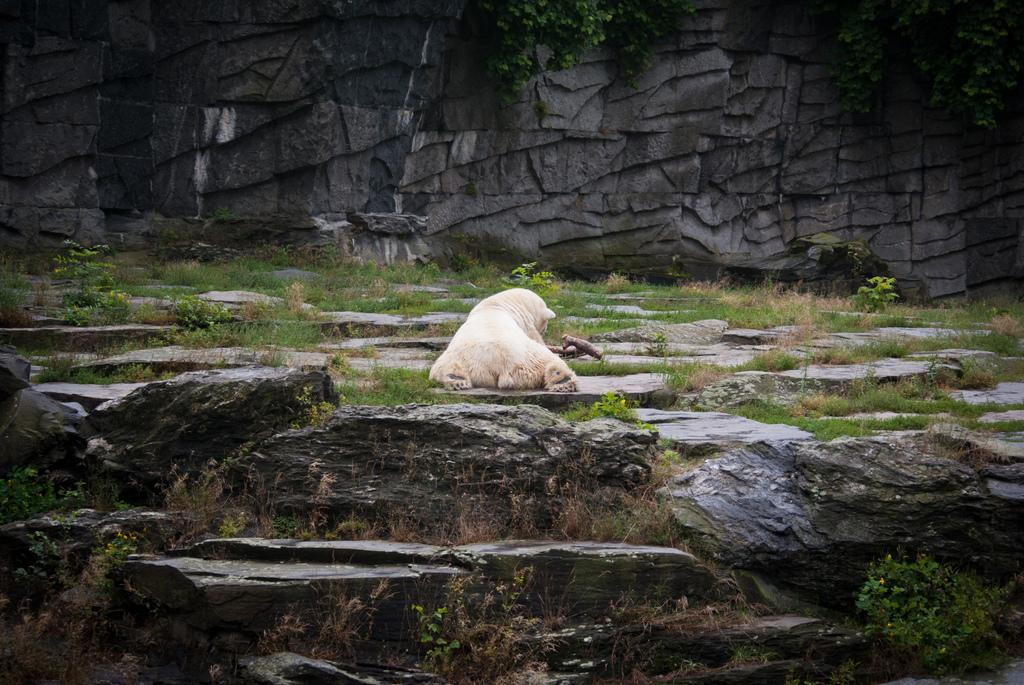What type of animal can be seen in the image? There is a white bear in the image. What natural elements are present in the image? There are rocks, grass, and leaves in the image. What man-made structure is visible in the image? There is a stone wall in the image. What type of collar is the bear wearing in the image? There is no collar visible on the bear in the image. 